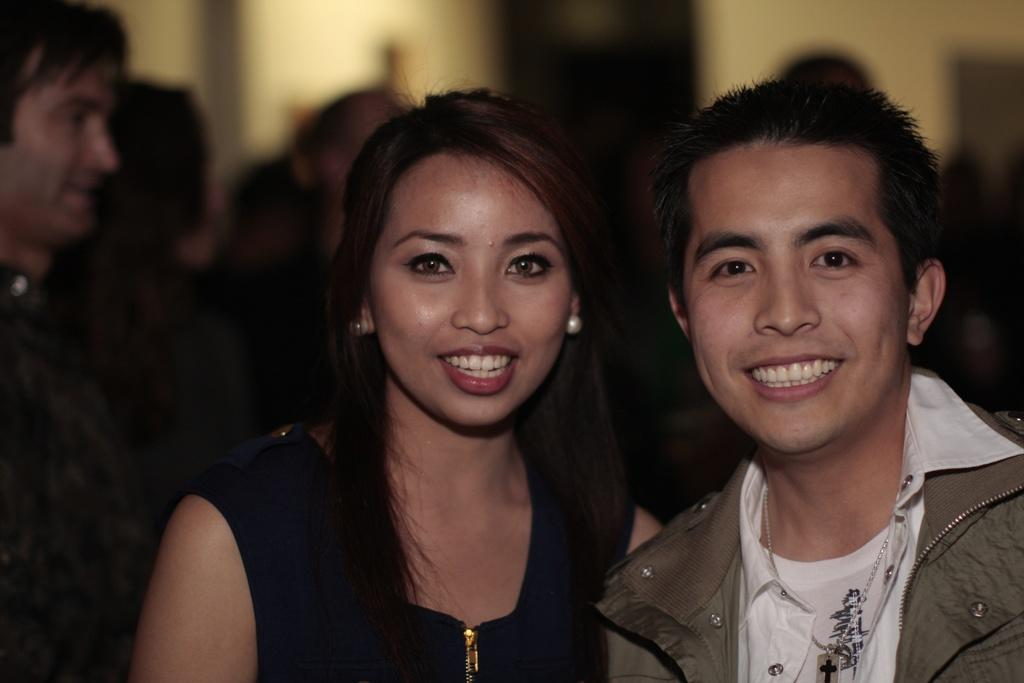How many people are in the center of the image? There are two people standing in the center of the image. What are the two people wearing? The two people are wearing dresses. What can be seen in the background of the image? There is a wall visible in the background of the image, and there are people standing there as well. What type of cherry is being used as a prop in the image? There is no cherry present in the image. Can you describe the playground equipment visible in the image? There is no playground equipment visible in the image. 